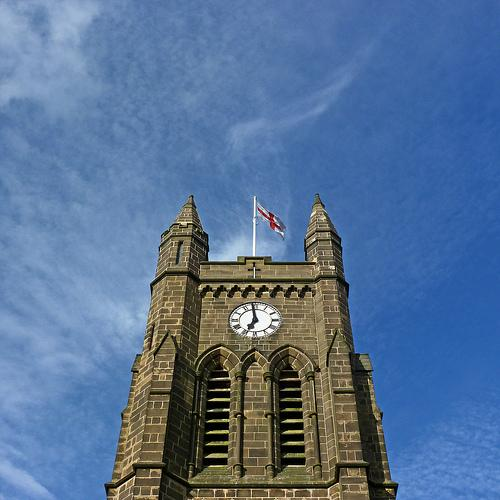Explain the design of the clock in the image. The clock is round with a white face, black Roman numerals, and black hands, including an hour hand, a minute hand, and it is fixed on the building. Examine the brick exterior of the tower and describe its appearance. The brick exterior of the tower is brown in color, showcasing an old-fashioned and traditional architectural design. What is the visual symbolic meaning denoted by the image as a whole? The image symbolizes a sense of tradition and history, represented by the old-fashioned brick tower, flag, and clock with Roman numerals. Please estimate the number of clouds that can be seen in the image. There are approximately 11 distinct parts of clouds visible in the image. Briefly describe the atmosphere and sentiment evoked by the image. The image evokes a nostalgic and old-world charm atmosphere, showcasing tradition and heritage in the architecture and design elements. How many windows can be identified on the brick tower, and what are some distinct traits? There are two windows on the brick tower, with slits in the window, giving an old-world appearance. Please provide details on the appearance of the flag present in the image. The flag is red and white, with a red cross in the middle, waving in the wind as it is mounted on a white pole on the tower. What type of building is the clock attached to, and what are some features of the building? The clock is attached to a tower that has a brown brick exterior, slits in the window, and a spire on top, symbolizing an old-fashioned architectural design. Can you describe the sky visible in the image? The sky is blue and white with thin clouds spread across. Several distinct parts of clouds are visible in various areas of the image. What type of numerals does the clock in the image feature? The clock features black Roman numerals. 